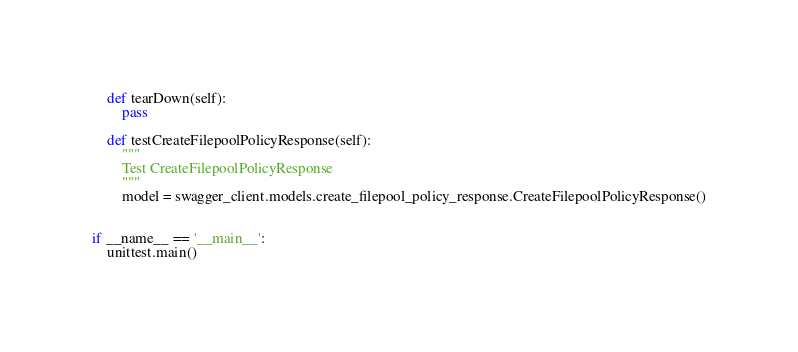Convert code to text. <code><loc_0><loc_0><loc_500><loc_500><_Python_>
    def tearDown(self):
        pass

    def testCreateFilepoolPolicyResponse(self):
        """
        Test CreateFilepoolPolicyResponse
        """
        model = swagger_client.models.create_filepool_policy_response.CreateFilepoolPolicyResponse()


if __name__ == '__main__':
    unittest.main()</code> 